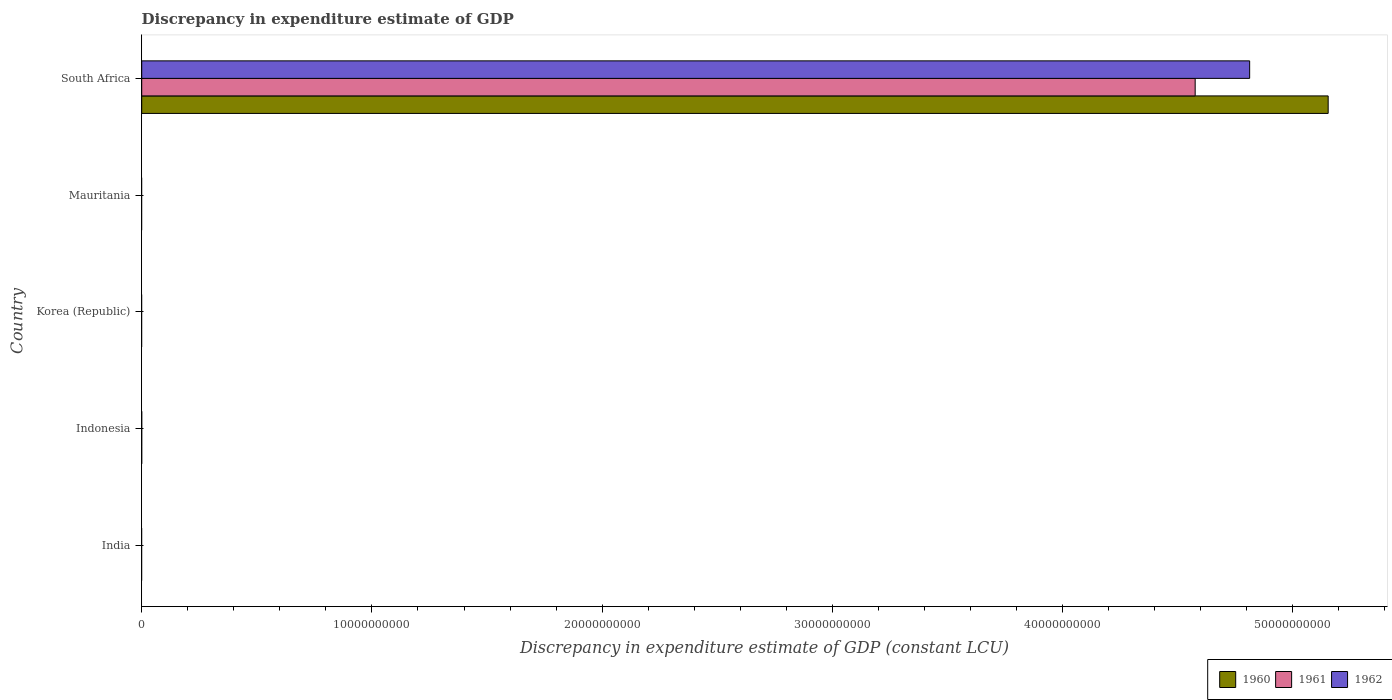How many different coloured bars are there?
Your response must be concise. 3. Are the number of bars per tick equal to the number of legend labels?
Keep it short and to the point. No. What is the label of the 1st group of bars from the top?
Provide a succinct answer. South Africa. What is the discrepancy in expenditure estimate of GDP in 1960 in Korea (Republic)?
Provide a succinct answer. 0. Across all countries, what is the maximum discrepancy in expenditure estimate of GDP in 1960?
Your answer should be very brief. 5.15e+1. In which country was the discrepancy in expenditure estimate of GDP in 1962 maximum?
Your answer should be very brief. South Africa. What is the total discrepancy in expenditure estimate of GDP in 1961 in the graph?
Your response must be concise. 4.58e+1. What is the average discrepancy in expenditure estimate of GDP in 1960 per country?
Provide a succinct answer. 1.03e+1. What is the difference between the discrepancy in expenditure estimate of GDP in 1962 and discrepancy in expenditure estimate of GDP in 1961 in South Africa?
Provide a short and direct response. 2.37e+09. In how many countries, is the discrepancy in expenditure estimate of GDP in 1962 greater than 30000000000 LCU?
Your answer should be compact. 1. What is the difference between the highest and the lowest discrepancy in expenditure estimate of GDP in 1961?
Keep it short and to the point. 4.58e+1. Is it the case that in every country, the sum of the discrepancy in expenditure estimate of GDP in 1962 and discrepancy in expenditure estimate of GDP in 1961 is greater than the discrepancy in expenditure estimate of GDP in 1960?
Your response must be concise. No. What is the difference between two consecutive major ticks on the X-axis?
Offer a very short reply. 1.00e+1. Does the graph contain grids?
Provide a short and direct response. No. Where does the legend appear in the graph?
Keep it short and to the point. Bottom right. How many legend labels are there?
Offer a terse response. 3. How are the legend labels stacked?
Your answer should be compact. Horizontal. What is the title of the graph?
Your response must be concise. Discrepancy in expenditure estimate of GDP. What is the label or title of the X-axis?
Your answer should be very brief. Discrepancy in expenditure estimate of GDP (constant LCU). What is the label or title of the Y-axis?
Keep it short and to the point. Country. What is the Discrepancy in expenditure estimate of GDP (constant LCU) of 1960 in India?
Offer a very short reply. 0. What is the Discrepancy in expenditure estimate of GDP (constant LCU) in 1960 in Indonesia?
Your answer should be very brief. 0. What is the Discrepancy in expenditure estimate of GDP (constant LCU) of 1961 in Indonesia?
Your answer should be compact. 0. What is the Discrepancy in expenditure estimate of GDP (constant LCU) of 1962 in Korea (Republic)?
Provide a succinct answer. 0. What is the Discrepancy in expenditure estimate of GDP (constant LCU) of 1961 in Mauritania?
Your answer should be compact. 0. What is the Discrepancy in expenditure estimate of GDP (constant LCU) in 1960 in South Africa?
Your answer should be compact. 5.15e+1. What is the Discrepancy in expenditure estimate of GDP (constant LCU) of 1961 in South Africa?
Your answer should be compact. 4.58e+1. What is the Discrepancy in expenditure estimate of GDP (constant LCU) of 1962 in South Africa?
Keep it short and to the point. 4.81e+1. Across all countries, what is the maximum Discrepancy in expenditure estimate of GDP (constant LCU) of 1960?
Provide a short and direct response. 5.15e+1. Across all countries, what is the maximum Discrepancy in expenditure estimate of GDP (constant LCU) of 1961?
Give a very brief answer. 4.58e+1. Across all countries, what is the maximum Discrepancy in expenditure estimate of GDP (constant LCU) of 1962?
Provide a succinct answer. 4.81e+1. Across all countries, what is the minimum Discrepancy in expenditure estimate of GDP (constant LCU) of 1962?
Provide a succinct answer. 0. What is the total Discrepancy in expenditure estimate of GDP (constant LCU) in 1960 in the graph?
Your answer should be very brief. 5.15e+1. What is the total Discrepancy in expenditure estimate of GDP (constant LCU) in 1961 in the graph?
Your answer should be very brief. 4.58e+1. What is the total Discrepancy in expenditure estimate of GDP (constant LCU) of 1962 in the graph?
Give a very brief answer. 4.81e+1. What is the average Discrepancy in expenditure estimate of GDP (constant LCU) of 1960 per country?
Your answer should be very brief. 1.03e+1. What is the average Discrepancy in expenditure estimate of GDP (constant LCU) of 1961 per country?
Offer a terse response. 9.15e+09. What is the average Discrepancy in expenditure estimate of GDP (constant LCU) of 1962 per country?
Provide a succinct answer. 9.62e+09. What is the difference between the Discrepancy in expenditure estimate of GDP (constant LCU) in 1960 and Discrepancy in expenditure estimate of GDP (constant LCU) in 1961 in South Africa?
Provide a short and direct response. 5.78e+09. What is the difference between the Discrepancy in expenditure estimate of GDP (constant LCU) in 1960 and Discrepancy in expenditure estimate of GDP (constant LCU) in 1962 in South Africa?
Your answer should be compact. 3.41e+09. What is the difference between the Discrepancy in expenditure estimate of GDP (constant LCU) of 1961 and Discrepancy in expenditure estimate of GDP (constant LCU) of 1962 in South Africa?
Provide a short and direct response. -2.37e+09. What is the difference between the highest and the lowest Discrepancy in expenditure estimate of GDP (constant LCU) of 1960?
Your answer should be compact. 5.15e+1. What is the difference between the highest and the lowest Discrepancy in expenditure estimate of GDP (constant LCU) in 1961?
Offer a very short reply. 4.58e+1. What is the difference between the highest and the lowest Discrepancy in expenditure estimate of GDP (constant LCU) of 1962?
Provide a succinct answer. 4.81e+1. 